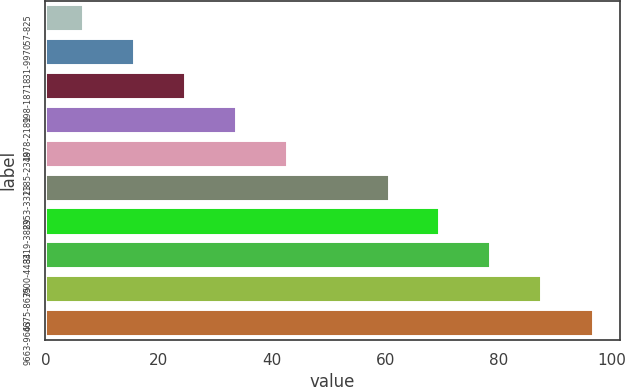Convert chart to OTSL. <chart><loc_0><loc_0><loc_500><loc_500><bar_chart><fcel>057-825<fcel>831-997<fcel>998-1871<fcel>1878-2181<fcel>2185-2349<fcel>2353-3313<fcel>3319-3889<fcel>3900-4484<fcel>4675-8675<fcel>9663-9663<nl><fcel>6.59<fcel>15.59<fcel>24.59<fcel>33.59<fcel>42.59<fcel>60.59<fcel>69.59<fcel>78.59<fcel>87.59<fcel>96.63<nl></chart> 